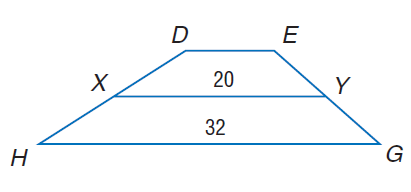Question: For trapezoid D E G H, X and Y are midpoints of the legs. Find D E.
Choices:
A. 8
B. 16
C. 20
D. 32
Answer with the letter. Answer: A 